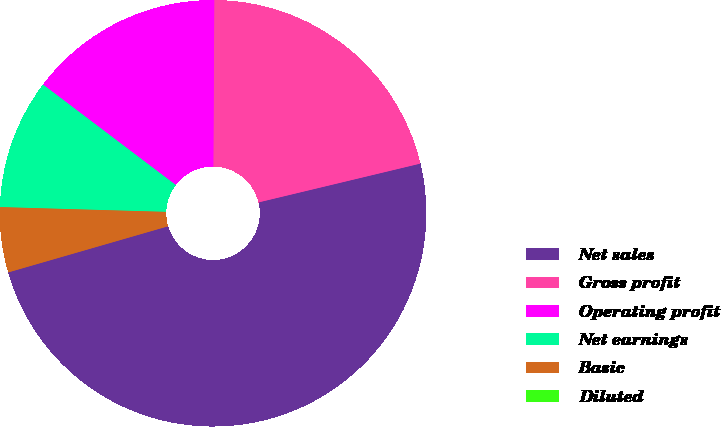Convert chart to OTSL. <chart><loc_0><loc_0><loc_500><loc_500><pie_chart><fcel>Net sales<fcel>Gross profit<fcel>Operating profit<fcel>Net earnings<fcel>Basic<fcel>Diluted<nl><fcel>49.27%<fcel>21.16%<fcel>14.78%<fcel>9.85%<fcel>4.93%<fcel>0.0%<nl></chart> 